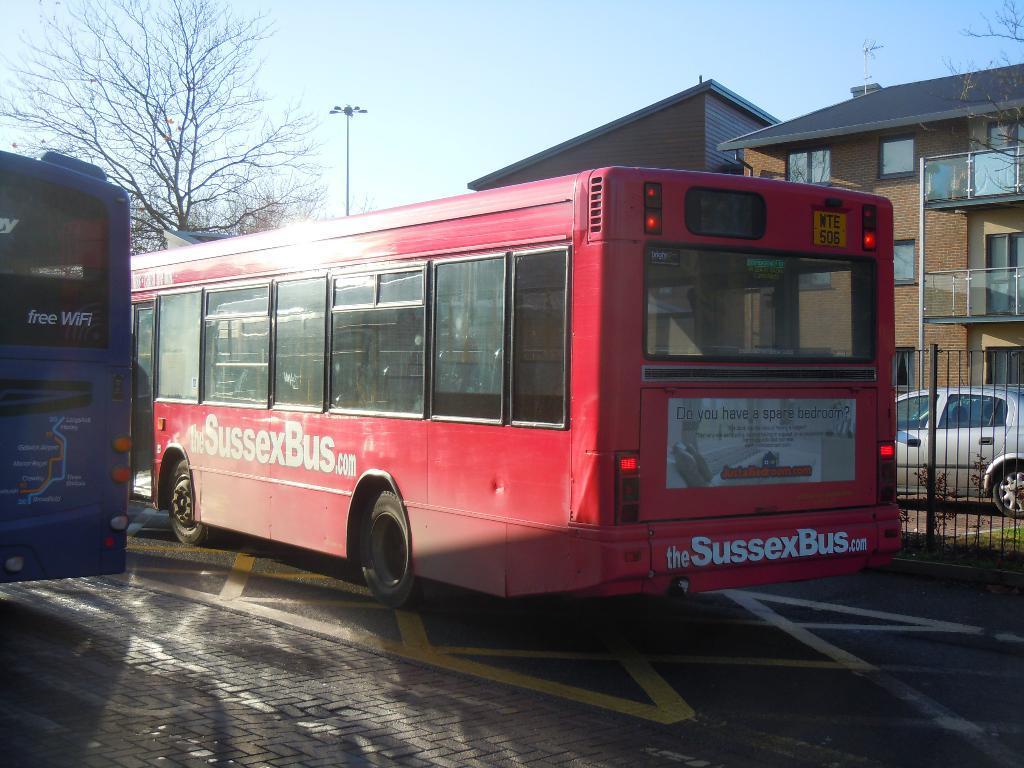Could you give a brief overview of what you see in this image? In the middle of this image, there is a bus on a road on which there is another bus. In the background, there are buildings, trees, a vehicle, a pole and there are clouds in the sky. 